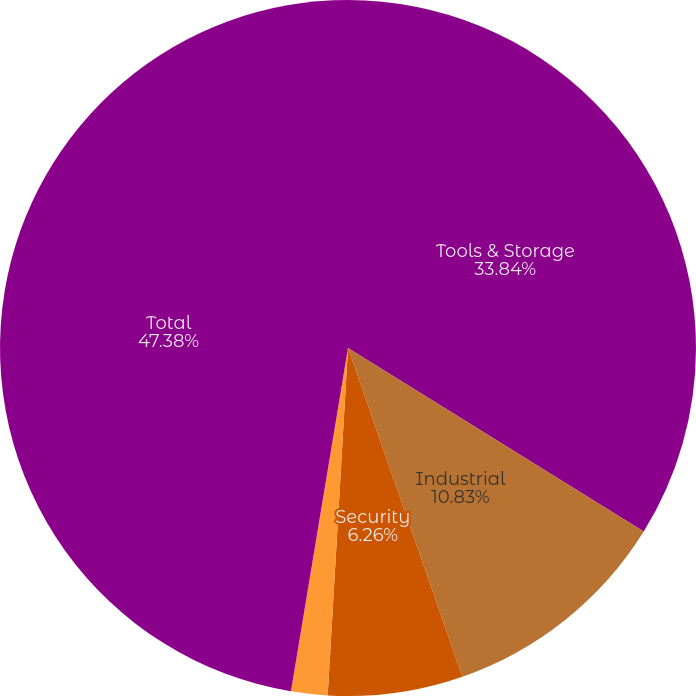<chart> <loc_0><loc_0><loc_500><loc_500><pie_chart><fcel>Tools & Storage<fcel>Industrial<fcel>Security<fcel>Corporate<fcel>Total<nl><fcel>33.84%<fcel>10.83%<fcel>6.26%<fcel>1.69%<fcel>47.38%<nl></chart> 